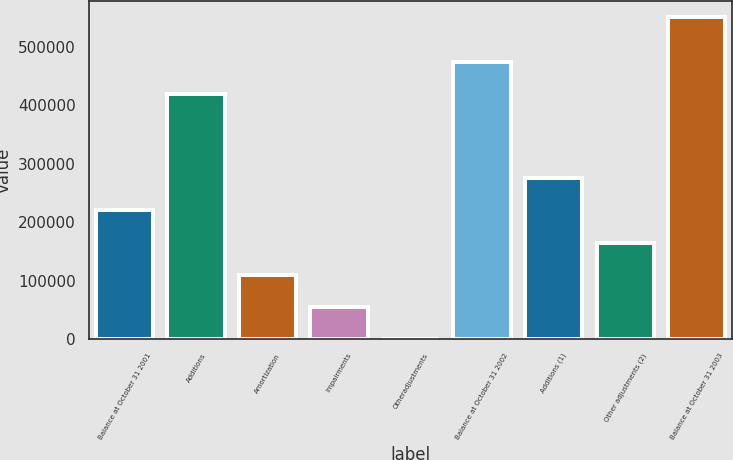Convert chart. <chart><loc_0><loc_0><loc_500><loc_500><bar_chart><fcel>Balance at October 31 2001<fcel>Additions<fcel>Amortization<fcel>Impairments<fcel>Otheradjustments<fcel>Balance at October 31 2002<fcel>Additions (1)<fcel>Other adjustments (2)<fcel>Balance at October 31 2003<nl><fcel>220348<fcel>419463<fcel>110220<fcel>55156<fcel>92<fcel>474527<fcel>275412<fcel>165284<fcel>550732<nl></chart> 